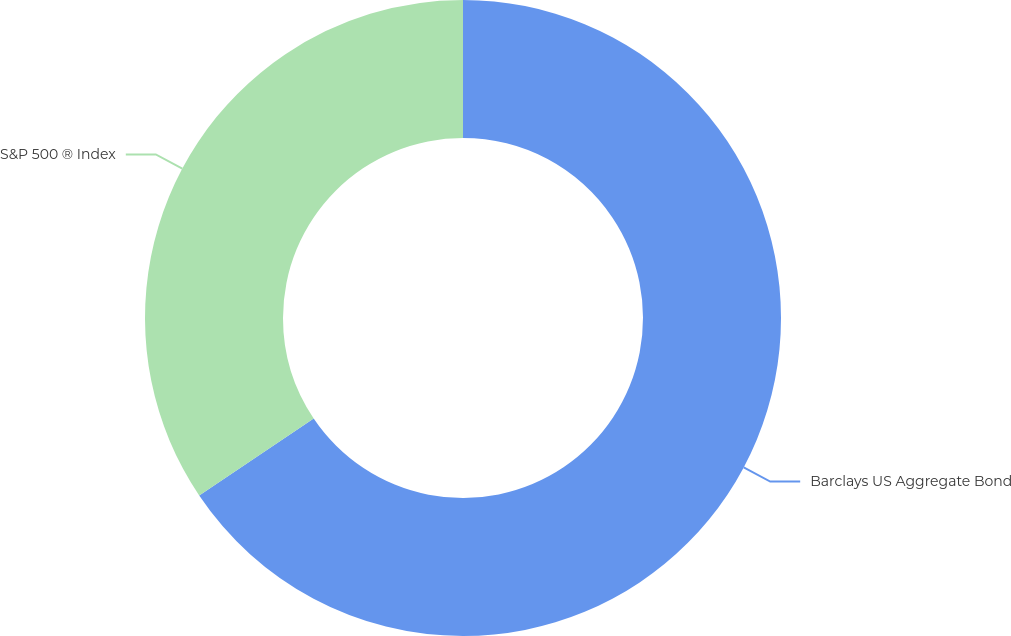Convert chart. <chart><loc_0><loc_0><loc_500><loc_500><pie_chart><fcel>Barclays US Aggregate Bond<fcel>S&P 500 ® Index<nl><fcel>65.57%<fcel>34.43%<nl></chart> 